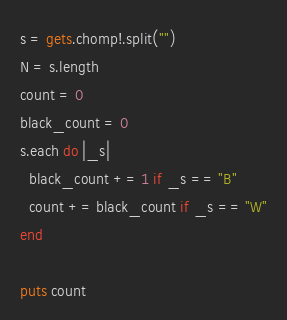Convert code to text. <code><loc_0><loc_0><loc_500><loc_500><_Ruby_>s = gets.chomp!.split("")
N = s.length
count = 0
black_count = 0
s.each do |_s|
  black_count += 1 if _s == "B"
  count += black_count if _s == "W"
end

puts count
</code> 